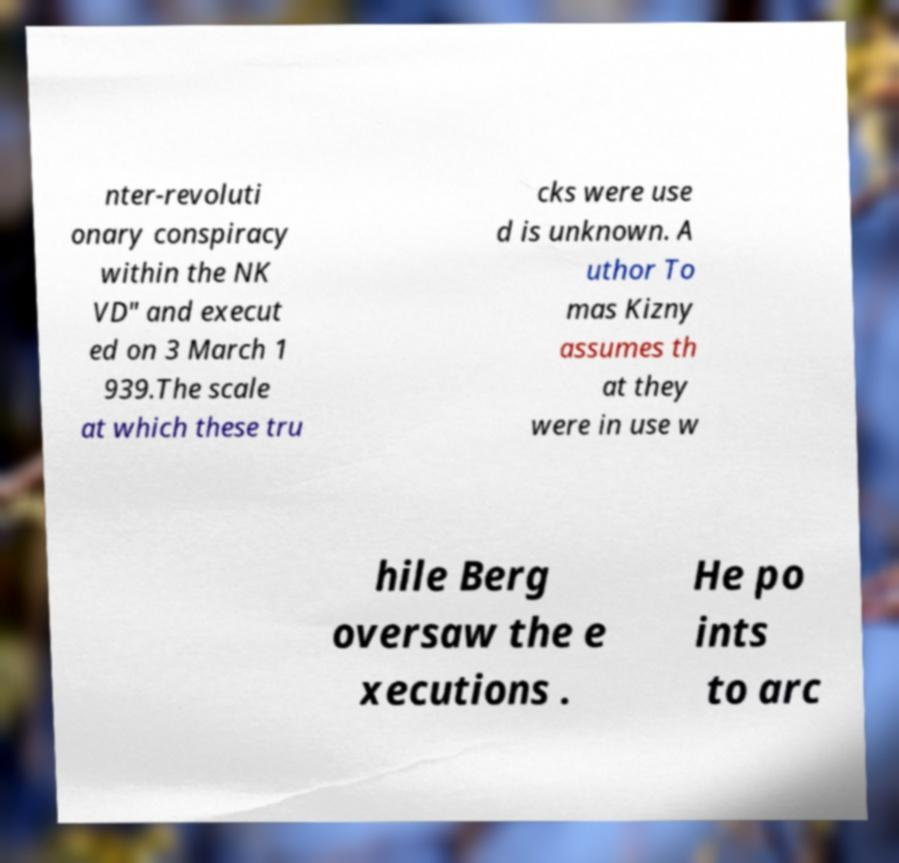What messages or text are displayed in this image? I need them in a readable, typed format. nter-revoluti onary conspiracy within the NK VD" and execut ed on 3 March 1 939.The scale at which these tru cks were use d is unknown. A uthor To mas Kizny assumes th at they were in use w hile Berg oversaw the e xecutions . He po ints to arc 